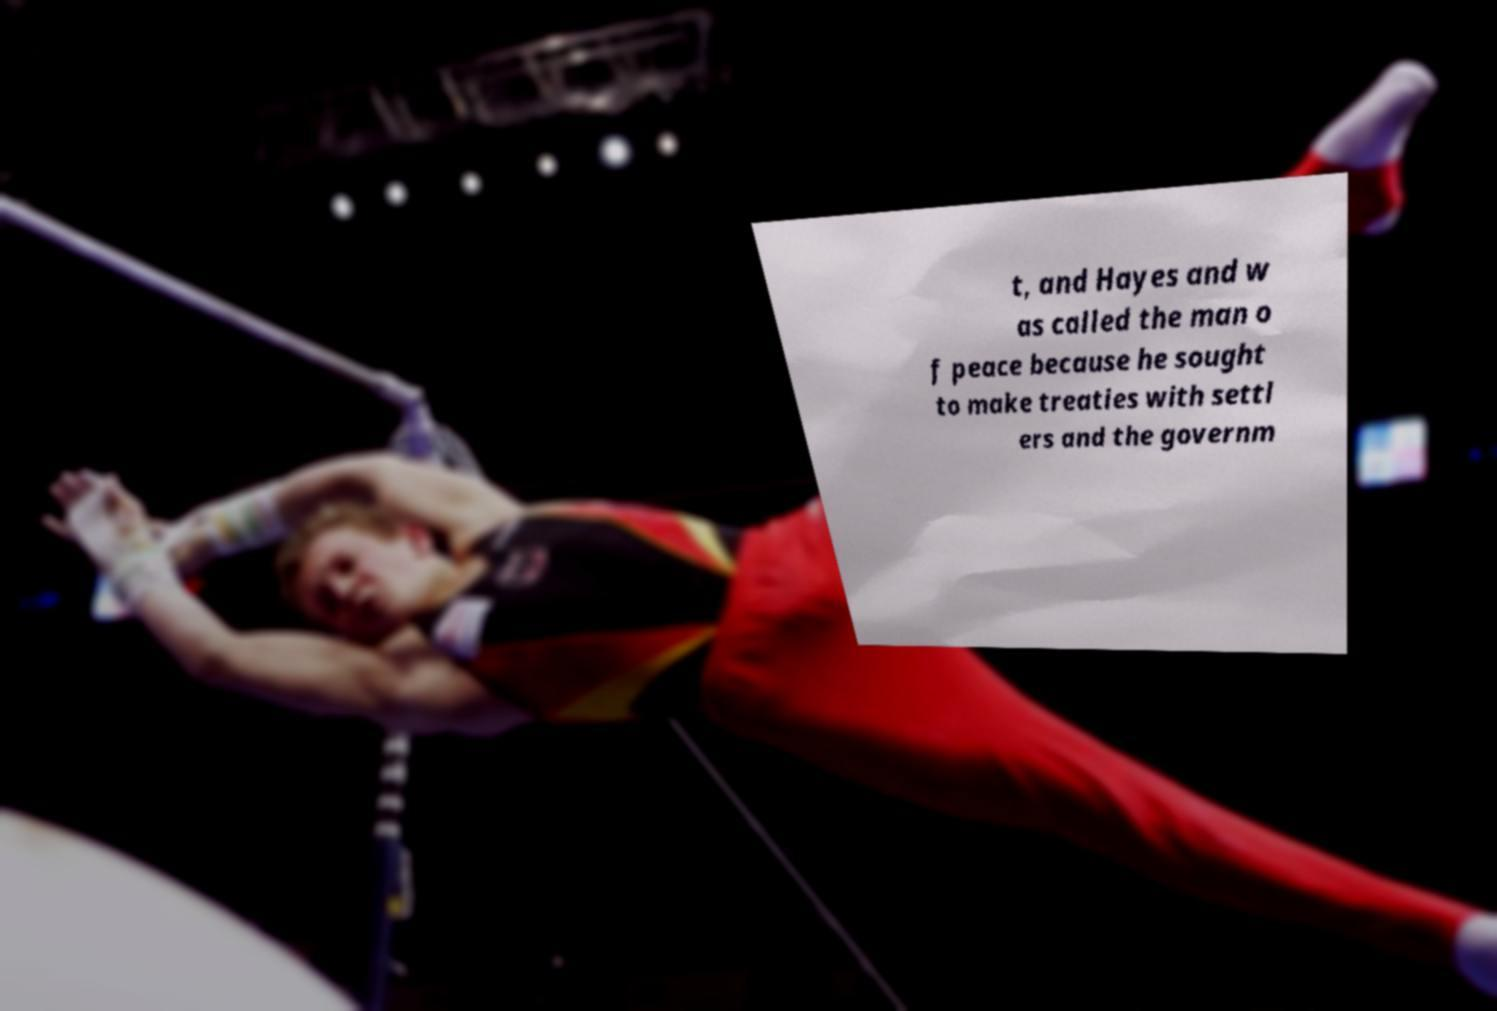Please identify and transcribe the text found in this image. t, and Hayes and w as called the man o f peace because he sought to make treaties with settl ers and the governm 